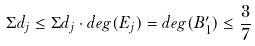Convert formula to latex. <formula><loc_0><loc_0><loc_500><loc_500>\Sigma d _ { j } \leq \Sigma d _ { j } \cdot d e g ( E _ { j } ) = d e g ( B _ { 1 } ^ { \prime } ) \leq \frac { 3 } { 7 }</formula> 